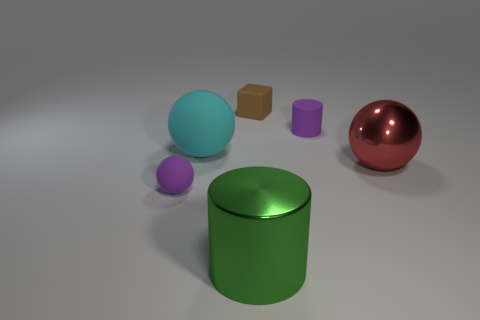What materials are the other objects potentially made of? The two cylinders could be made of a matte metal or plastic judging by their less reflective surface, while the cube may be made of wood or plastic due to its opaque and non-reflective texture. 